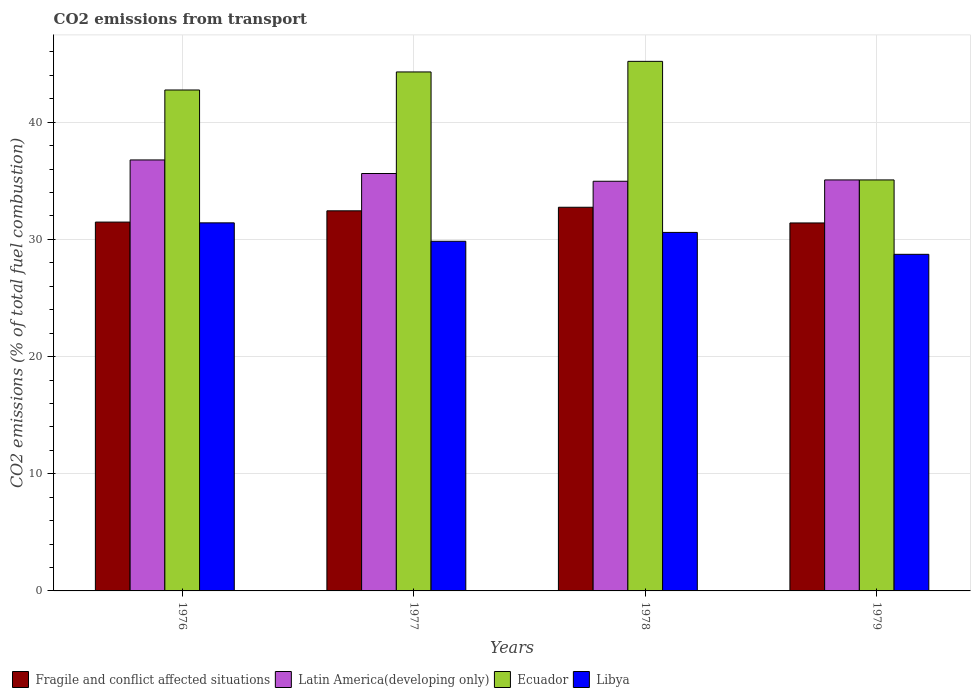Are the number of bars per tick equal to the number of legend labels?
Your answer should be compact. Yes. How many bars are there on the 4th tick from the left?
Your answer should be very brief. 4. How many bars are there on the 4th tick from the right?
Give a very brief answer. 4. What is the label of the 3rd group of bars from the left?
Your response must be concise. 1978. What is the total CO2 emitted in Libya in 1977?
Offer a terse response. 29.84. Across all years, what is the maximum total CO2 emitted in Fragile and conflict affected situations?
Keep it short and to the point. 32.74. Across all years, what is the minimum total CO2 emitted in Fragile and conflict affected situations?
Provide a short and direct response. 31.4. In which year was the total CO2 emitted in Latin America(developing only) maximum?
Offer a very short reply. 1976. In which year was the total CO2 emitted in Libya minimum?
Provide a short and direct response. 1979. What is the total total CO2 emitted in Latin America(developing only) in the graph?
Offer a very short reply. 142.45. What is the difference between the total CO2 emitted in Ecuador in 1977 and that in 1978?
Your answer should be compact. -0.9. What is the difference between the total CO2 emitted in Fragile and conflict affected situations in 1978 and the total CO2 emitted in Latin America(developing only) in 1979?
Keep it short and to the point. -2.33. What is the average total CO2 emitted in Ecuador per year?
Provide a succinct answer. 41.83. In the year 1976, what is the difference between the total CO2 emitted in Fragile and conflict affected situations and total CO2 emitted in Latin America(developing only)?
Keep it short and to the point. -5.3. What is the ratio of the total CO2 emitted in Latin America(developing only) in 1976 to that in 1977?
Provide a succinct answer. 1.03. Is the total CO2 emitted in Ecuador in 1978 less than that in 1979?
Offer a very short reply. No. Is the difference between the total CO2 emitted in Fragile and conflict affected situations in 1976 and 1977 greater than the difference between the total CO2 emitted in Latin America(developing only) in 1976 and 1977?
Offer a terse response. No. What is the difference between the highest and the second highest total CO2 emitted in Latin America(developing only)?
Make the answer very short. 1.16. What is the difference between the highest and the lowest total CO2 emitted in Fragile and conflict affected situations?
Give a very brief answer. 1.34. In how many years, is the total CO2 emitted in Ecuador greater than the average total CO2 emitted in Ecuador taken over all years?
Make the answer very short. 3. Is the sum of the total CO2 emitted in Latin America(developing only) in 1977 and 1979 greater than the maximum total CO2 emitted in Libya across all years?
Offer a terse response. Yes. What does the 2nd bar from the left in 1976 represents?
Provide a short and direct response. Latin America(developing only). What does the 2nd bar from the right in 1978 represents?
Your response must be concise. Ecuador. Is it the case that in every year, the sum of the total CO2 emitted in Libya and total CO2 emitted in Latin America(developing only) is greater than the total CO2 emitted in Ecuador?
Keep it short and to the point. Yes. How many bars are there?
Your response must be concise. 16. Are all the bars in the graph horizontal?
Give a very brief answer. No. How many years are there in the graph?
Your response must be concise. 4. Does the graph contain grids?
Keep it short and to the point. Yes. Where does the legend appear in the graph?
Your answer should be very brief. Bottom left. What is the title of the graph?
Offer a very short reply. CO2 emissions from transport. Does "Latin America(developing only)" appear as one of the legend labels in the graph?
Keep it short and to the point. Yes. What is the label or title of the X-axis?
Make the answer very short. Years. What is the label or title of the Y-axis?
Your answer should be very brief. CO2 emissions (% of total fuel combustion). What is the CO2 emissions (% of total fuel combustion) in Fragile and conflict affected situations in 1976?
Make the answer very short. 31.48. What is the CO2 emissions (% of total fuel combustion) of Latin America(developing only) in 1976?
Offer a very short reply. 36.78. What is the CO2 emissions (% of total fuel combustion) in Ecuador in 1976?
Your answer should be compact. 42.75. What is the CO2 emissions (% of total fuel combustion) in Libya in 1976?
Give a very brief answer. 31.41. What is the CO2 emissions (% of total fuel combustion) in Fragile and conflict affected situations in 1977?
Your answer should be very brief. 32.44. What is the CO2 emissions (% of total fuel combustion) in Latin America(developing only) in 1977?
Your answer should be very brief. 35.62. What is the CO2 emissions (% of total fuel combustion) in Ecuador in 1977?
Ensure brevity in your answer.  44.29. What is the CO2 emissions (% of total fuel combustion) of Libya in 1977?
Your response must be concise. 29.84. What is the CO2 emissions (% of total fuel combustion) in Fragile and conflict affected situations in 1978?
Ensure brevity in your answer.  32.74. What is the CO2 emissions (% of total fuel combustion) in Latin America(developing only) in 1978?
Make the answer very short. 34.96. What is the CO2 emissions (% of total fuel combustion) in Ecuador in 1978?
Provide a succinct answer. 45.2. What is the CO2 emissions (% of total fuel combustion) in Libya in 1978?
Offer a very short reply. 30.6. What is the CO2 emissions (% of total fuel combustion) in Fragile and conflict affected situations in 1979?
Offer a very short reply. 31.4. What is the CO2 emissions (% of total fuel combustion) of Latin America(developing only) in 1979?
Your response must be concise. 35.08. What is the CO2 emissions (% of total fuel combustion) of Ecuador in 1979?
Offer a very short reply. 35.08. What is the CO2 emissions (% of total fuel combustion) in Libya in 1979?
Ensure brevity in your answer.  28.73. Across all years, what is the maximum CO2 emissions (% of total fuel combustion) in Fragile and conflict affected situations?
Offer a very short reply. 32.74. Across all years, what is the maximum CO2 emissions (% of total fuel combustion) in Latin America(developing only)?
Provide a succinct answer. 36.78. Across all years, what is the maximum CO2 emissions (% of total fuel combustion) in Ecuador?
Ensure brevity in your answer.  45.2. Across all years, what is the maximum CO2 emissions (% of total fuel combustion) of Libya?
Provide a short and direct response. 31.41. Across all years, what is the minimum CO2 emissions (% of total fuel combustion) of Fragile and conflict affected situations?
Ensure brevity in your answer.  31.4. Across all years, what is the minimum CO2 emissions (% of total fuel combustion) in Latin America(developing only)?
Provide a short and direct response. 34.96. Across all years, what is the minimum CO2 emissions (% of total fuel combustion) in Ecuador?
Make the answer very short. 35.08. Across all years, what is the minimum CO2 emissions (% of total fuel combustion) of Libya?
Your answer should be compact. 28.73. What is the total CO2 emissions (% of total fuel combustion) in Fragile and conflict affected situations in the graph?
Give a very brief answer. 128.07. What is the total CO2 emissions (% of total fuel combustion) in Latin America(developing only) in the graph?
Offer a very short reply. 142.45. What is the total CO2 emissions (% of total fuel combustion) of Ecuador in the graph?
Your answer should be very brief. 167.32. What is the total CO2 emissions (% of total fuel combustion) of Libya in the graph?
Provide a succinct answer. 120.58. What is the difference between the CO2 emissions (% of total fuel combustion) of Fragile and conflict affected situations in 1976 and that in 1977?
Your response must be concise. -0.96. What is the difference between the CO2 emissions (% of total fuel combustion) of Latin America(developing only) in 1976 and that in 1977?
Make the answer very short. 1.16. What is the difference between the CO2 emissions (% of total fuel combustion) in Ecuador in 1976 and that in 1977?
Make the answer very short. -1.54. What is the difference between the CO2 emissions (% of total fuel combustion) in Libya in 1976 and that in 1977?
Your response must be concise. 1.57. What is the difference between the CO2 emissions (% of total fuel combustion) of Fragile and conflict affected situations in 1976 and that in 1978?
Provide a succinct answer. -1.27. What is the difference between the CO2 emissions (% of total fuel combustion) of Latin America(developing only) in 1976 and that in 1978?
Keep it short and to the point. 1.82. What is the difference between the CO2 emissions (% of total fuel combustion) of Ecuador in 1976 and that in 1978?
Your response must be concise. -2.44. What is the difference between the CO2 emissions (% of total fuel combustion) in Libya in 1976 and that in 1978?
Give a very brief answer. 0.82. What is the difference between the CO2 emissions (% of total fuel combustion) of Fragile and conflict affected situations in 1976 and that in 1979?
Make the answer very short. 0.07. What is the difference between the CO2 emissions (% of total fuel combustion) in Latin America(developing only) in 1976 and that in 1979?
Give a very brief answer. 1.71. What is the difference between the CO2 emissions (% of total fuel combustion) of Ecuador in 1976 and that in 1979?
Give a very brief answer. 7.68. What is the difference between the CO2 emissions (% of total fuel combustion) in Libya in 1976 and that in 1979?
Provide a short and direct response. 2.69. What is the difference between the CO2 emissions (% of total fuel combustion) in Fragile and conflict affected situations in 1977 and that in 1978?
Offer a terse response. -0.3. What is the difference between the CO2 emissions (% of total fuel combustion) in Latin America(developing only) in 1977 and that in 1978?
Your answer should be very brief. 0.66. What is the difference between the CO2 emissions (% of total fuel combustion) in Ecuador in 1977 and that in 1978?
Provide a succinct answer. -0.9. What is the difference between the CO2 emissions (% of total fuel combustion) of Libya in 1977 and that in 1978?
Your response must be concise. -0.76. What is the difference between the CO2 emissions (% of total fuel combustion) of Fragile and conflict affected situations in 1977 and that in 1979?
Provide a succinct answer. 1.03. What is the difference between the CO2 emissions (% of total fuel combustion) in Latin America(developing only) in 1977 and that in 1979?
Your response must be concise. 0.55. What is the difference between the CO2 emissions (% of total fuel combustion) in Ecuador in 1977 and that in 1979?
Provide a short and direct response. 9.22. What is the difference between the CO2 emissions (% of total fuel combustion) of Libya in 1977 and that in 1979?
Your response must be concise. 1.11. What is the difference between the CO2 emissions (% of total fuel combustion) of Fragile and conflict affected situations in 1978 and that in 1979?
Your answer should be very brief. 1.34. What is the difference between the CO2 emissions (% of total fuel combustion) in Latin America(developing only) in 1978 and that in 1979?
Offer a very short reply. -0.11. What is the difference between the CO2 emissions (% of total fuel combustion) in Ecuador in 1978 and that in 1979?
Your response must be concise. 10.12. What is the difference between the CO2 emissions (% of total fuel combustion) of Libya in 1978 and that in 1979?
Provide a succinct answer. 1.87. What is the difference between the CO2 emissions (% of total fuel combustion) in Fragile and conflict affected situations in 1976 and the CO2 emissions (% of total fuel combustion) in Latin America(developing only) in 1977?
Ensure brevity in your answer.  -4.15. What is the difference between the CO2 emissions (% of total fuel combustion) in Fragile and conflict affected situations in 1976 and the CO2 emissions (% of total fuel combustion) in Ecuador in 1977?
Provide a succinct answer. -12.81. What is the difference between the CO2 emissions (% of total fuel combustion) of Fragile and conflict affected situations in 1976 and the CO2 emissions (% of total fuel combustion) of Libya in 1977?
Your answer should be very brief. 1.64. What is the difference between the CO2 emissions (% of total fuel combustion) of Latin America(developing only) in 1976 and the CO2 emissions (% of total fuel combustion) of Ecuador in 1977?
Your answer should be very brief. -7.51. What is the difference between the CO2 emissions (% of total fuel combustion) in Latin America(developing only) in 1976 and the CO2 emissions (% of total fuel combustion) in Libya in 1977?
Your answer should be compact. 6.94. What is the difference between the CO2 emissions (% of total fuel combustion) in Ecuador in 1976 and the CO2 emissions (% of total fuel combustion) in Libya in 1977?
Your answer should be compact. 12.91. What is the difference between the CO2 emissions (% of total fuel combustion) of Fragile and conflict affected situations in 1976 and the CO2 emissions (% of total fuel combustion) of Latin America(developing only) in 1978?
Provide a short and direct response. -3.48. What is the difference between the CO2 emissions (% of total fuel combustion) of Fragile and conflict affected situations in 1976 and the CO2 emissions (% of total fuel combustion) of Ecuador in 1978?
Ensure brevity in your answer.  -13.72. What is the difference between the CO2 emissions (% of total fuel combustion) of Fragile and conflict affected situations in 1976 and the CO2 emissions (% of total fuel combustion) of Libya in 1978?
Keep it short and to the point. 0.88. What is the difference between the CO2 emissions (% of total fuel combustion) in Latin America(developing only) in 1976 and the CO2 emissions (% of total fuel combustion) in Ecuador in 1978?
Your response must be concise. -8.41. What is the difference between the CO2 emissions (% of total fuel combustion) in Latin America(developing only) in 1976 and the CO2 emissions (% of total fuel combustion) in Libya in 1978?
Provide a succinct answer. 6.19. What is the difference between the CO2 emissions (% of total fuel combustion) in Ecuador in 1976 and the CO2 emissions (% of total fuel combustion) in Libya in 1978?
Provide a short and direct response. 12.16. What is the difference between the CO2 emissions (% of total fuel combustion) in Fragile and conflict affected situations in 1976 and the CO2 emissions (% of total fuel combustion) in Latin America(developing only) in 1979?
Keep it short and to the point. -3.6. What is the difference between the CO2 emissions (% of total fuel combustion) of Fragile and conflict affected situations in 1976 and the CO2 emissions (% of total fuel combustion) of Ecuador in 1979?
Your response must be concise. -3.6. What is the difference between the CO2 emissions (% of total fuel combustion) of Fragile and conflict affected situations in 1976 and the CO2 emissions (% of total fuel combustion) of Libya in 1979?
Your answer should be compact. 2.75. What is the difference between the CO2 emissions (% of total fuel combustion) of Latin America(developing only) in 1976 and the CO2 emissions (% of total fuel combustion) of Ecuador in 1979?
Your answer should be compact. 1.71. What is the difference between the CO2 emissions (% of total fuel combustion) of Latin America(developing only) in 1976 and the CO2 emissions (% of total fuel combustion) of Libya in 1979?
Make the answer very short. 8.05. What is the difference between the CO2 emissions (% of total fuel combustion) in Ecuador in 1976 and the CO2 emissions (% of total fuel combustion) in Libya in 1979?
Your answer should be compact. 14.02. What is the difference between the CO2 emissions (% of total fuel combustion) of Fragile and conflict affected situations in 1977 and the CO2 emissions (% of total fuel combustion) of Latin America(developing only) in 1978?
Make the answer very short. -2.52. What is the difference between the CO2 emissions (% of total fuel combustion) of Fragile and conflict affected situations in 1977 and the CO2 emissions (% of total fuel combustion) of Ecuador in 1978?
Offer a terse response. -12.76. What is the difference between the CO2 emissions (% of total fuel combustion) of Fragile and conflict affected situations in 1977 and the CO2 emissions (% of total fuel combustion) of Libya in 1978?
Your answer should be compact. 1.84. What is the difference between the CO2 emissions (% of total fuel combustion) in Latin America(developing only) in 1977 and the CO2 emissions (% of total fuel combustion) in Ecuador in 1978?
Your response must be concise. -9.57. What is the difference between the CO2 emissions (% of total fuel combustion) of Latin America(developing only) in 1977 and the CO2 emissions (% of total fuel combustion) of Libya in 1978?
Ensure brevity in your answer.  5.03. What is the difference between the CO2 emissions (% of total fuel combustion) in Ecuador in 1977 and the CO2 emissions (% of total fuel combustion) in Libya in 1978?
Offer a terse response. 13.7. What is the difference between the CO2 emissions (% of total fuel combustion) of Fragile and conflict affected situations in 1977 and the CO2 emissions (% of total fuel combustion) of Latin America(developing only) in 1979?
Make the answer very short. -2.64. What is the difference between the CO2 emissions (% of total fuel combustion) of Fragile and conflict affected situations in 1977 and the CO2 emissions (% of total fuel combustion) of Ecuador in 1979?
Offer a terse response. -2.64. What is the difference between the CO2 emissions (% of total fuel combustion) of Fragile and conflict affected situations in 1977 and the CO2 emissions (% of total fuel combustion) of Libya in 1979?
Your response must be concise. 3.71. What is the difference between the CO2 emissions (% of total fuel combustion) in Latin America(developing only) in 1977 and the CO2 emissions (% of total fuel combustion) in Ecuador in 1979?
Ensure brevity in your answer.  0.55. What is the difference between the CO2 emissions (% of total fuel combustion) in Latin America(developing only) in 1977 and the CO2 emissions (% of total fuel combustion) in Libya in 1979?
Provide a succinct answer. 6.9. What is the difference between the CO2 emissions (% of total fuel combustion) of Ecuador in 1977 and the CO2 emissions (% of total fuel combustion) of Libya in 1979?
Keep it short and to the point. 15.56. What is the difference between the CO2 emissions (% of total fuel combustion) of Fragile and conflict affected situations in 1978 and the CO2 emissions (% of total fuel combustion) of Latin America(developing only) in 1979?
Offer a very short reply. -2.33. What is the difference between the CO2 emissions (% of total fuel combustion) in Fragile and conflict affected situations in 1978 and the CO2 emissions (% of total fuel combustion) in Ecuador in 1979?
Ensure brevity in your answer.  -2.33. What is the difference between the CO2 emissions (% of total fuel combustion) in Fragile and conflict affected situations in 1978 and the CO2 emissions (% of total fuel combustion) in Libya in 1979?
Your answer should be compact. 4.02. What is the difference between the CO2 emissions (% of total fuel combustion) in Latin America(developing only) in 1978 and the CO2 emissions (% of total fuel combustion) in Ecuador in 1979?
Offer a terse response. -0.11. What is the difference between the CO2 emissions (% of total fuel combustion) in Latin America(developing only) in 1978 and the CO2 emissions (% of total fuel combustion) in Libya in 1979?
Your answer should be very brief. 6.24. What is the difference between the CO2 emissions (% of total fuel combustion) of Ecuador in 1978 and the CO2 emissions (% of total fuel combustion) of Libya in 1979?
Give a very brief answer. 16.47. What is the average CO2 emissions (% of total fuel combustion) in Fragile and conflict affected situations per year?
Offer a very short reply. 32.02. What is the average CO2 emissions (% of total fuel combustion) in Latin America(developing only) per year?
Offer a very short reply. 35.61. What is the average CO2 emissions (% of total fuel combustion) in Ecuador per year?
Offer a very short reply. 41.83. What is the average CO2 emissions (% of total fuel combustion) of Libya per year?
Offer a terse response. 30.14. In the year 1976, what is the difference between the CO2 emissions (% of total fuel combustion) in Fragile and conflict affected situations and CO2 emissions (% of total fuel combustion) in Latin America(developing only)?
Your answer should be very brief. -5.3. In the year 1976, what is the difference between the CO2 emissions (% of total fuel combustion) in Fragile and conflict affected situations and CO2 emissions (% of total fuel combustion) in Ecuador?
Your answer should be very brief. -11.27. In the year 1976, what is the difference between the CO2 emissions (% of total fuel combustion) of Fragile and conflict affected situations and CO2 emissions (% of total fuel combustion) of Libya?
Your answer should be compact. 0.07. In the year 1976, what is the difference between the CO2 emissions (% of total fuel combustion) of Latin America(developing only) and CO2 emissions (% of total fuel combustion) of Ecuador?
Offer a terse response. -5.97. In the year 1976, what is the difference between the CO2 emissions (% of total fuel combustion) of Latin America(developing only) and CO2 emissions (% of total fuel combustion) of Libya?
Offer a terse response. 5.37. In the year 1976, what is the difference between the CO2 emissions (% of total fuel combustion) in Ecuador and CO2 emissions (% of total fuel combustion) in Libya?
Your response must be concise. 11.34. In the year 1977, what is the difference between the CO2 emissions (% of total fuel combustion) in Fragile and conflict affected situations and CO2 emissions (% of total fuel combustion) in Latin America(developing only)?
Provide a succinct answer. -3.18. In the year 1977, what is the difference between the CO2 emissions (% of total fuel combustion) of Fragile and conflict affected situations and CO2 emissions (% of total fuel combustion) of Ecuador?
Your response must be concise. -11.85. In the year 1977, what is the difference between the CO2 emissions (% of total fuel combustion) of Fragile and conflict affected situations and CO2 emissions (% of total fuel combustion) of Libya?
Give a very brief answer. 2.6. In the year 1977, what is the difference between the CO2 emissions (% of total fuel combustion) of Latin America(developing only) and CO2 emissions (% of total fuel combustion) of Ecuador?
Make the answer very short. -8.67. In the year 1977, what is the difference between the CO2 emissions (% of total fuel combustion) of Latin America(developing only) and CO2 emissions (% of total fuel combustion) of Libya?
Provide a short and direct response. 5.78. In the year 1977, what is the difference between the CO2 emissions (% of total fuel combustion) of Ecuador and CO2 emissions (% of total fuel combustion) of Libya?
Your answer should be compact. 14.45. In the year 1978, what is the difference between the CO2 emissions (% of total fuel combustion) in Fragile and conflict affected situations and CO2 emissions (% of total fuel combustion) in Latin America(developing only)?
Your answer should be very brief. -2.22. In the year 1978, what is the difference between the CO2 emissions (% of total fuel combustion) in Fragile and conflict affected situations and CO2 emissions (% of total fuel combustion) in Ecuador?
Your response must be concise. -12.45. In the year 1978, what is the difference between the CO2 emissions (% of total fuel combustion) in Fragile and conflict affected situations and CO2 emissions (% of total fuel combustion) in Libya?
Offer a very short reply. 2.15. In the year 1978, what is the difference between the CO2 emissions (% of total fuel combustion) in Latin America(developing only) and CO2 emissions (% of total fuel combustion) in Ecuador?
Offer a very short reply. -10.23. In the year 1978, what is the difference between the CO2 emissions (% of total fuel combustion) in Latin America(developing only) and CO2 emissions (% of total fuel combustion) in Libya?
Your answer should be very brief. 4.37. In the year 1978, what is the difference between the CO2 emissions (% of total fuel combustion) in Ecuador and CO2 emissions (% of total fuel combustion) in Libya?
Give a very brief answer. 14.6. In the year 1979, what is the difference between the CO2 emissions (% of total fuel combustion) in Fragile and conflict affected situations and CO2 emissions (% of total fuel combustion) in Latin America(developing only)?
Ensure brevity in your answer.  -3.67. In the year 1979, what is the difference between the CO2 emissions (% of total fuel combustion) of Fragile and conflict affected situations and CO2 emissions (% of total fuel combustion) of Ecuador?
Offer a terse response. -3.67. In the year 1979, what is the difference between the CO2 emissions (% of total fuel combustion) in Fragile and conflict affected situations and CO2 emissions (% of total fuel combustion) in Libya?
Give a very brief answer. 2.68. In the year 1979, what is the difference between the CO2 emissions (% of total fuel combustion) of Latin America(developing only) and CO2 emissions (% of total fuel combustion) of Ecuador?
Give a very brief answer. -0. In the year 1979, what is the difference between the CO2 emissions (% of total fuel combustion) in Latin America(developing only) and CO2 emissions (% of total fuel combustion) in Libya?
Give a very brief answer. 6.35. In the year 1979, what is the difference between the CO2 emissions (% of total fuel combustion) of Ecuador and CO2 emissions (% of total fuel combustion) of Libya?
Offer a very short reply. 6.35. What is the ratio of the CO2 emissions (% of total fuel combustion) in Fragile and conflict affected situations in 1976 to that in 1977?
Give a very brief answer. 0.97. What is the ratio of the CO2 emissions (% of total fuel combustion) in Latin America(developing only) in 1976 to that in 1977?
Offer a very short reply. 1.03. What is the ratio of the CO2 emissions (% of total fuel combustion) of Ecuador in 1976 to that in 1977?
Provide a short and direct response. 0.97. What is the ratio of the CO2 emissions (% of total fuel combustion) of Libya in 1976 to that in 1977?
Make the answer very short. 1.05. What is the ratio of the CO2 emissions (% of total fuel combustion) in Fragile and conflict affected situations in 1976 to that in 1978?
Provide a short and direct response. 0.96. What is the ratio of the CO2 emissions (% of total fuel combustion) in Latin America(developing only) in 1976 to that in 1978?
Provide a short and direct response. 1.05. What is the ratio of the CO2 emissions (% of total fuel combustion) in Ecuador in 1976 to that in 1978?
Offer a very short reply. 0.95. What is the ratio of the CO2 emissions (% of total fuel combustion) of Libya in 1976 to that in 1978?
Your answer should be compact. 1.03. What is the ratio of the CO2 emissions (% of total fuel combustion) in Latin America(developing only) in 1976 to that in 1979?
Offer a very short reply. 1.05. What is the ratio of the CO2 emissions (% of total fuel combustion) of Ecuador in 1976 to that in 1979?
Provide a short and direct response. 1.22. What is the ratio of the CO2 emissions (% of total fuel combustion) of Libya in 1976 to that in 1979?
Your answer should be compact. 1.09. What is the ratio of the CO2 emissions (% of total fuel combustion) of Latin America(developing only) in 1977 to that in 1978?
Make the answer very short. 1.02. What is the ratio of the CO2 emissions (% of total fuel combustion) of Libya in 1977 to that in 1978?
Give a very brief answer. 0.98. What is the ratio of the CO2 emissions (% of total fuel combustion) in Fragile and conflict affected situations in 1977 to that in 1979?
Provide a short and direct response. 1.03. What is the ratio of the CO2 emissions (% of total fuel combustion) in Latin America(developing only) in 1977 to that in 1979?
Offer a very short reply. 1.02. What is the ratio of the CO2 emissions (% of total fuel combustion) of Ecuador in 1977 to that in 1979?
Give a very brief answer. 1.26. What is the ratio of the CO2 emissions (% of total fuel combustion) of Libya in 1977 to that in 1979?
Keep it short and to the point. 1.04. What is the ratio of the CO2 emissions (% of total fuel combustion) of Fragile and conflict affected situations in 1978 to that in 1979?
Provide a short and direct response. 1.04. What is the ratio of the CO2 emissions (% of total fuel combustion) of Latin America(developing only) in 1978 to that in 1979?
Offer a terse response. 1. What is the ratio of the CO2 emissions (% of total fuel combustion) of Ecuador in 1978 to that in 1979?
Offer a terse response. 1.29. What is the ratio of the CO2 emissions (% of total fuel combustion) of Libya in 1978 to that in 1979?
Give a very brief answer. 1.07. What is the difference between the highest and the second highest CO2 emissions (% of total fuel combustion) of Fragile and conflict affected situations?
Provide a succinct answer. 0.3. What is the difference between the highest and the second highest CO2 emissions (% of total fuel combustion) of Latin America(developing only)?
Provide a succinct answer. 1.16. What is the difference between the highest and the second highest CO2 emissions (% of total fuel combustion) in Ecuador?
Ensure brevity in your answer.  0.9. What is the difference between the highest and the second highest CO2 emissions (% of total fuel combustion) of Libya?
Your response must be concise. 0.82. What is the difference between the highest and the lowest CO2 emissions (% of total fuel combustion) in Fragile and conflict affected situations?
Offer a terse response. 1.34. What is the difference between the highest and the lowest CO2 emissions (% of total fuel combustion) in Latin America(developing only)?
Ensure brevity in your answer.  1.82. What is the difference between the highest and the lowest CO2 emissions (% of total fuel combustion) in Ecuador?
Your answer should be very brief. 10.12. What is the difference between the highest and the lowest CO2 emissions (% of total fuel combustion) of Libya?
Your response must be concise. 2.69. 